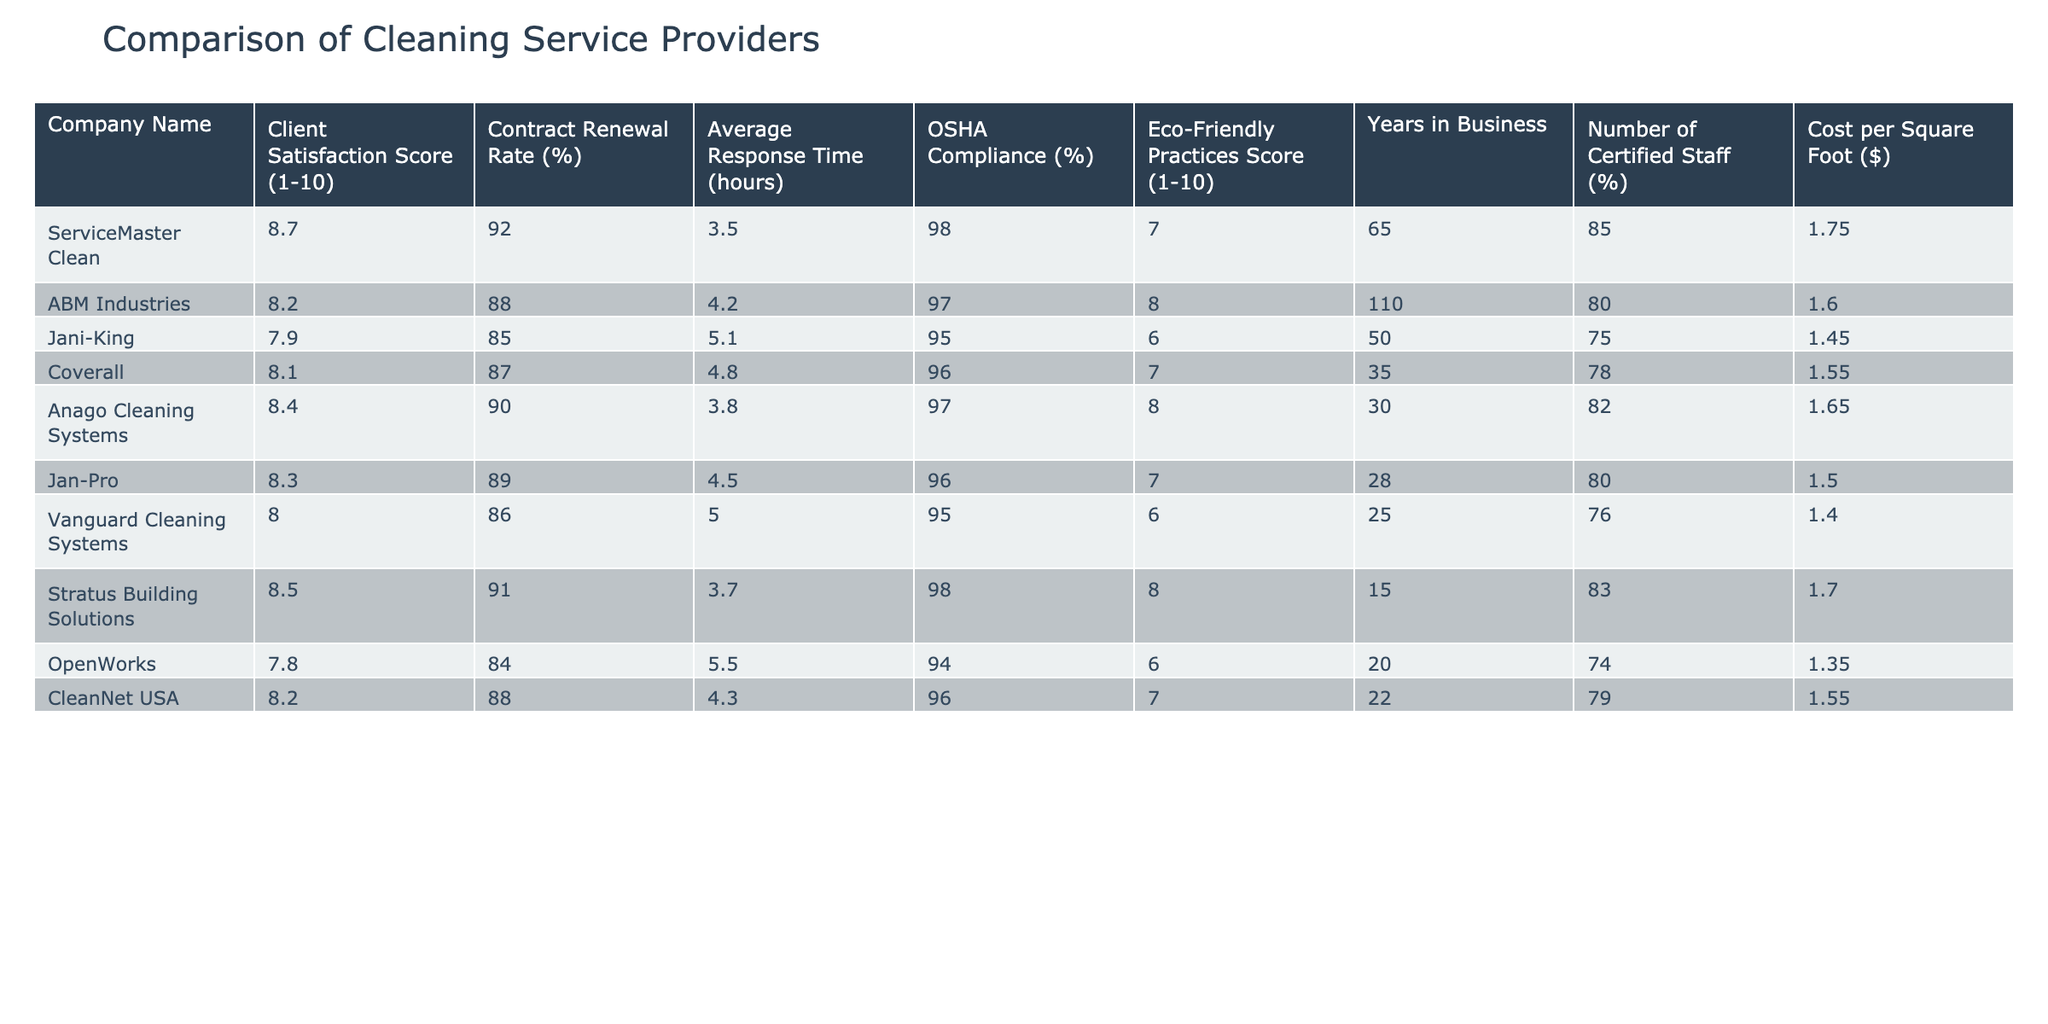What is the client satisfaction score of ServiceMaster Clean? The client satisfaction score for ServiceMaster Clean is listed in the table as 8.7.
Answer: 8.7 Which company has the highest contract renewal rate? By examining the contract renewal rates of each company, ServiceMaster Clean has the highest renewal rate at 92%.
Answer: 92% What is the average contract renewal rate across all companies? To find the average, we sum the contract renewal rates (92 + 88 + 85 + 87 + 90 + 89 + 86 + 91 + 84 + 88 = 879), and then divide by the number of companies (10). Thus, 879/10 = 87.9%.
Answer: 87.9% Does Jani-King have a higher OSHA compliance percentage than Coverall? Jani-King's OSHA compliance rate is 95%, while Coverall's is 96%. Since 95% is less than 96%, the statement is false.
Answer: No What is the difference in average response time between the best and worst companies? The best average response time is 3.5 hours for ServiceMaster Clean, and the worst is 5.5 hours for OpenWorks. The difference is 5.5 - 3.5 = 2 hours.
Answer: 2 hours Which company has the best eco-friendly practices score, and what is that score? Anago Cleaning Systems and ABM Industries both have the highest eco-friendly practices score of 8. Based on the table, we determine that these two companies share this score.
Answer: 8 How many years in business does the company with the lowest contract renewal rate have? Vanguard Cleaning Systems has the lowest contract renewal rate at 86%. Referring to the table, Vanguard Cleaning Systems has been in business for 25 years.
Answer: 25 years Is the average cost per square foot higher for companies with satisfaction scores below 8? Companies with scores below 8 (Jani-King at 7.9 and OpenWorks at 7.8) have costs at $1.45 and $1.35 respectively. The average is (1.45 + 1.35) / 2 = $1.40, which is lower than the average of higher scoring companies. Thus, the statement is true.
Answer: Yes What percentage of certified staff does the company with the longest years in business have? ABM Industries, which has been in business for 110 years, has 80% certified staff according to the table.
Answer: 80% 